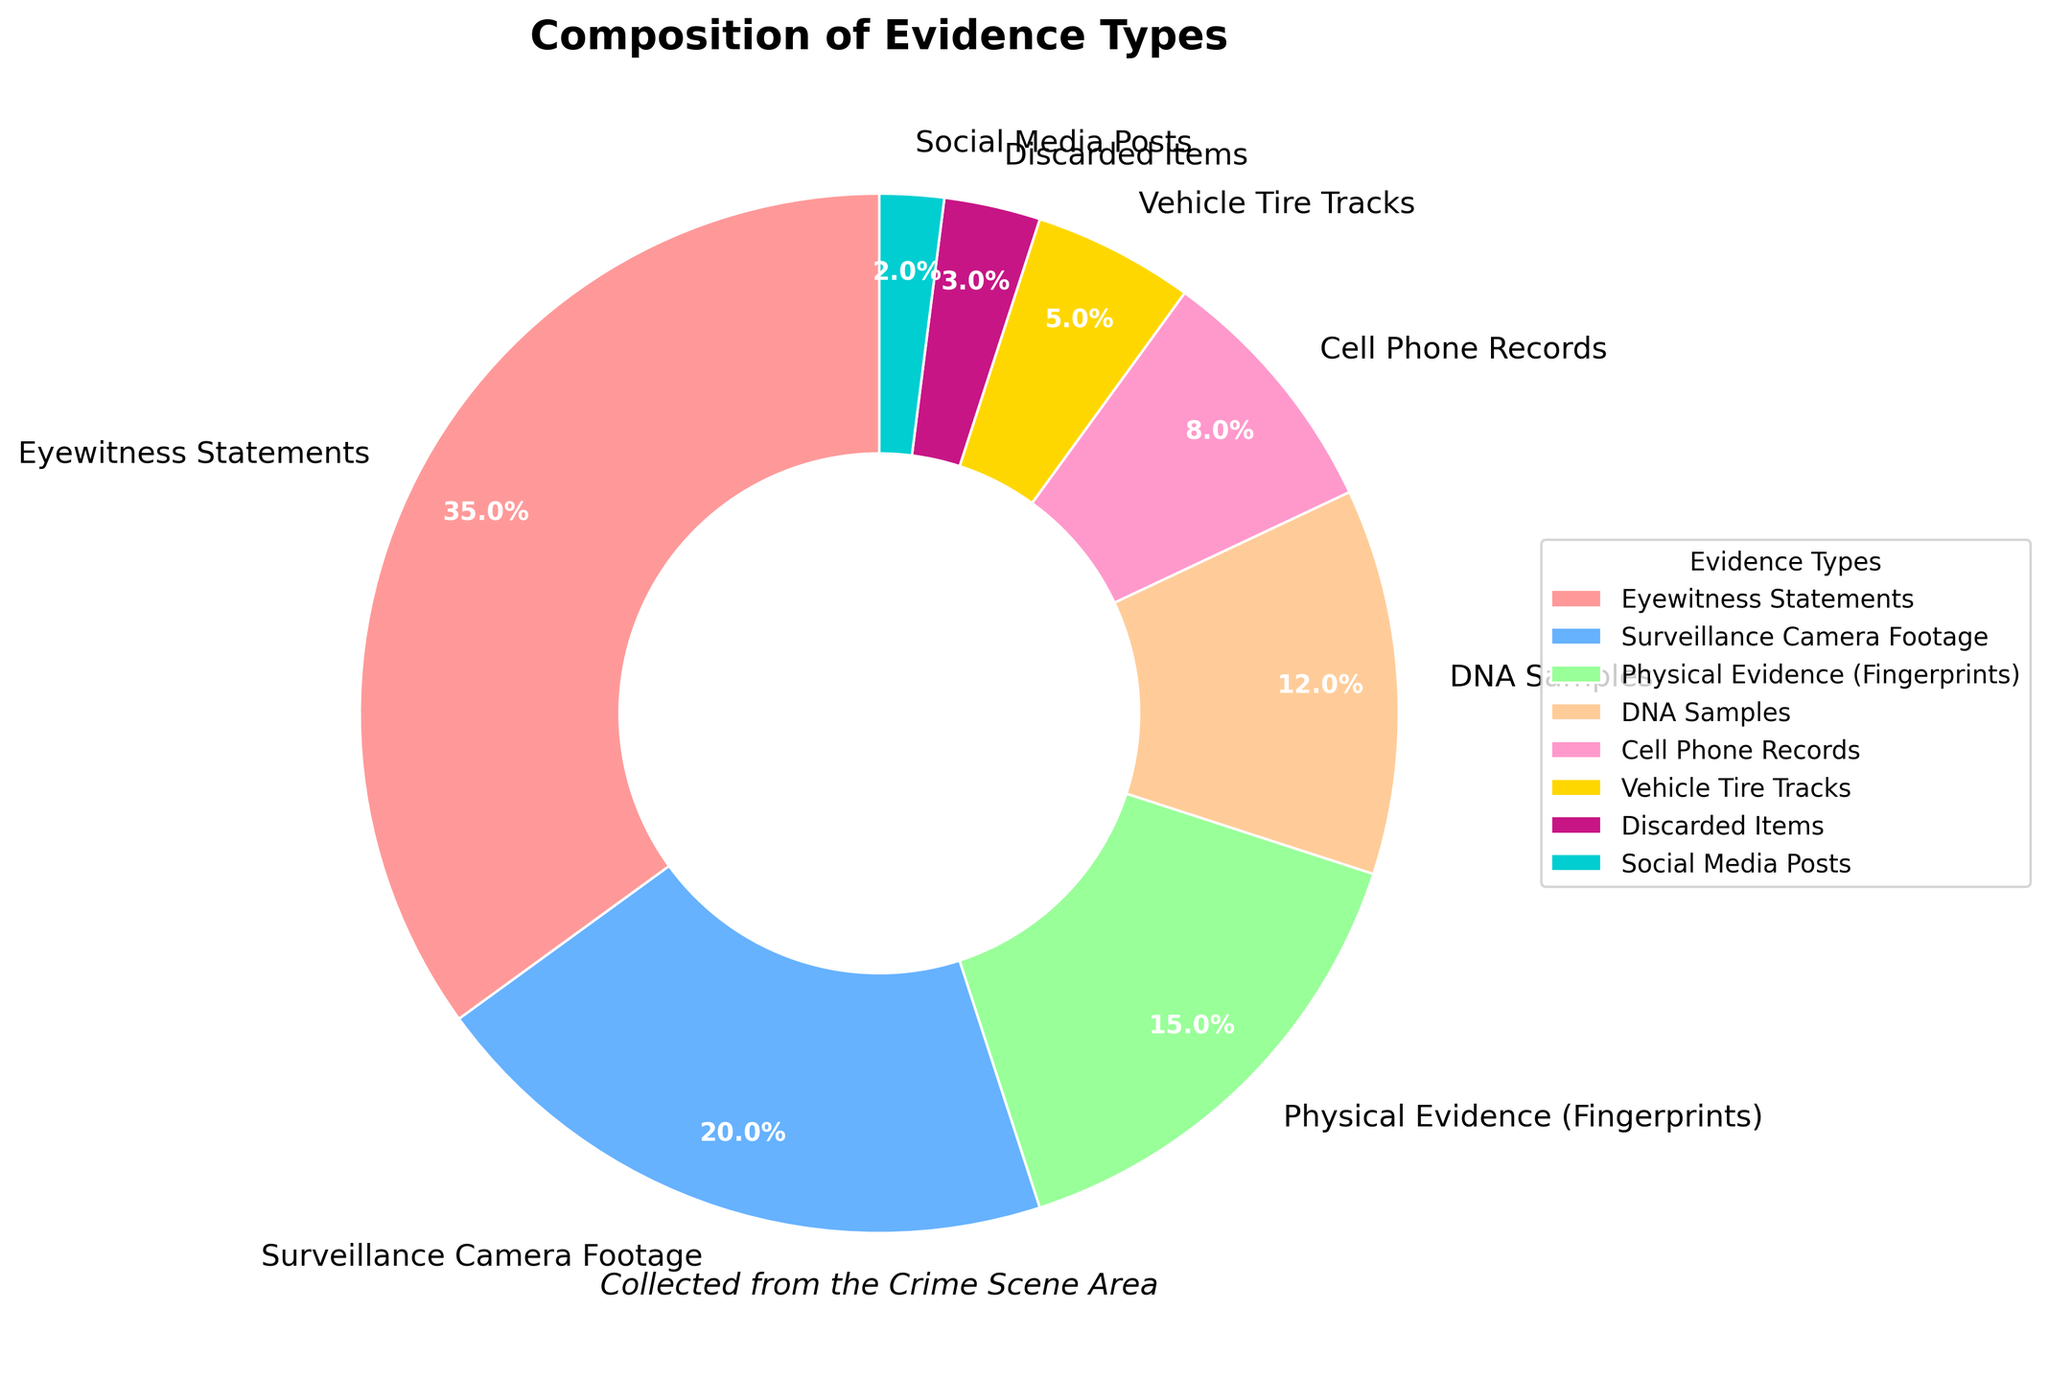Which evidence type has the highest percentage? The largest section in the pie chart represents the evidence type with the highest percentage. Eyewitness Statements have the largest section.
Answer: Eyewitness Statements Which evidence type has the lowest percentage? The smallest section in the pie chart represents the evidence type with the lowest percentage. Social Media Posts have the smallest section.
Answer: Social Media Posts What is the combined percentage of DNA Samples and Cell Phone Records? Locate the segments for DNA Samples and Cell Phone Records, which are 12% and 8%, respectively. Add these percentages: 12% + 8% = 20%.
Answer: 20% How does Physical Evidence (Fingerprints) compare to Surveillance Camera Footage in terms of percentage? Check the percentages of both segments. Physical Evidence (Fingerprints) is 15%, and Surveillance Camera Footage is 20%. Surveillance Camera Footage has a higher percentage.
Answer: Surveillance Camera Footage is higher What is the total percentage of evidence types that account for less than 10% individually? Identify and add the percentages of evidence types with less than 10%: Cell Phone Records (8%), Vehicle Tire Tracks (5%), Discarded Items (3%), and Social Media Posts (2%). Sum them up: 8% + 5% + 3% + 2% = 18%.
Answer: 18% Which evidence types have a percentage that is above the average percentage of all evidence types? Calculate the average percentage: sum all percentages (100%) and divide by the number of evidence types (8): 100/8 = 12.5%. Identify the types above this average: Eyewitness Statements (35%), Surveillance Camera Footage (20%), and Physical Evidence (Fingerprints) (15%).
Answer: Eyewitness Statements, Surveillance Camera Footage, Physical Evidence (Fingerprints) What is the difference in percentage between Eyewitness Statements and Discarded Items? Subtract the percentage of Discarded Items from Eyewitness Statements: 35% - 3% = 32%.
Answer: 32% Among the segments, which colors are used for the evidence types with percentages higher than 15%? Identify the segments with percentages higher than 15%: Eyewitness Statements (35%), Surveillance Camera Footage (20%), and Physical Evidence (Fingerprints) (15%). Their colors are red (Eyewitness Statements), blue (Surveillance Camera Footage), and light green (Physical Evidence).
Answer: Red, Blue, Light Green What percentage of evidence types are not related to direct human activities (Eyewitness Statements, Social Media Posts)? Add percentages for evidence types not directly involving human activities: Surveillance Camera Footage (20%), Physical Evidence (Fingerprints) (15%), DNA Samples (12%), Cell Phone Records (8%), Vehicle Tire Tracks (5%), Discarded Items (3%): 20% + 15% + 12% + 8% + 5% + 3% = 63%
Answer: 63% 